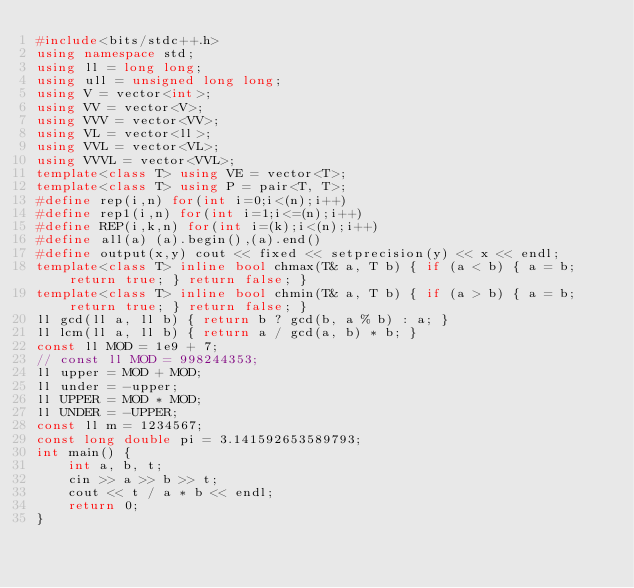<code> <loc_0><loc_0><loc_500><loc_500><_C++_>#include<bits/stdc++.h>
using namespace std;
using ll = long long;
using ull = unsigned long long;
using V = vector<int>;
using VV = vector<V>;
using VVV = vector<VV>;
using VL = vector<ll>;
using VVL = vector<VL>;
using VVVL = vector<VVL>;
template<class T> using VE = vector<T>;
template<class T> using P = pair<T, T>;
#define rep(i,n) for(int i=0;i<(n);i++)
#define rep1(i,n) for(int i=1;i<=(n);i++)
#define REP(i,k,n) for(int i=(k);i<(n);i++)
#define all(a) (a).begin(),(a).end()
#define output(x,y) cout << fixed << setprecision(y) << x << endl;
template<class T> inline bool chmax(T& a, T b) { if (a < b) { a = b; return true; } return false; }
template<class T> inline bool chmin(T& a, T b) { if (a > b) { a = b; return true; } return false; }
ll gcd(ll a, ll b) { return b ? gcd(b, a % b) : a; }
ll lcm(ll a, ll b) { return a / gcd(a, b) * b; }
const ll MOD = 1e9 + 7;
// const ll MOD = 998244353;
ll upper = MOD + MOD;
ll under = -upper;
ll UPPER = MOD * MOD;
ll UNDER = -UPPER;
const ll m = 1234567;
const long double pi = 3.141592653589793;
int main() {
	int a, b, t;
	cin >> a >> b >> t;
	cout << t / a * b << endl;
	return 0;
}</code> 